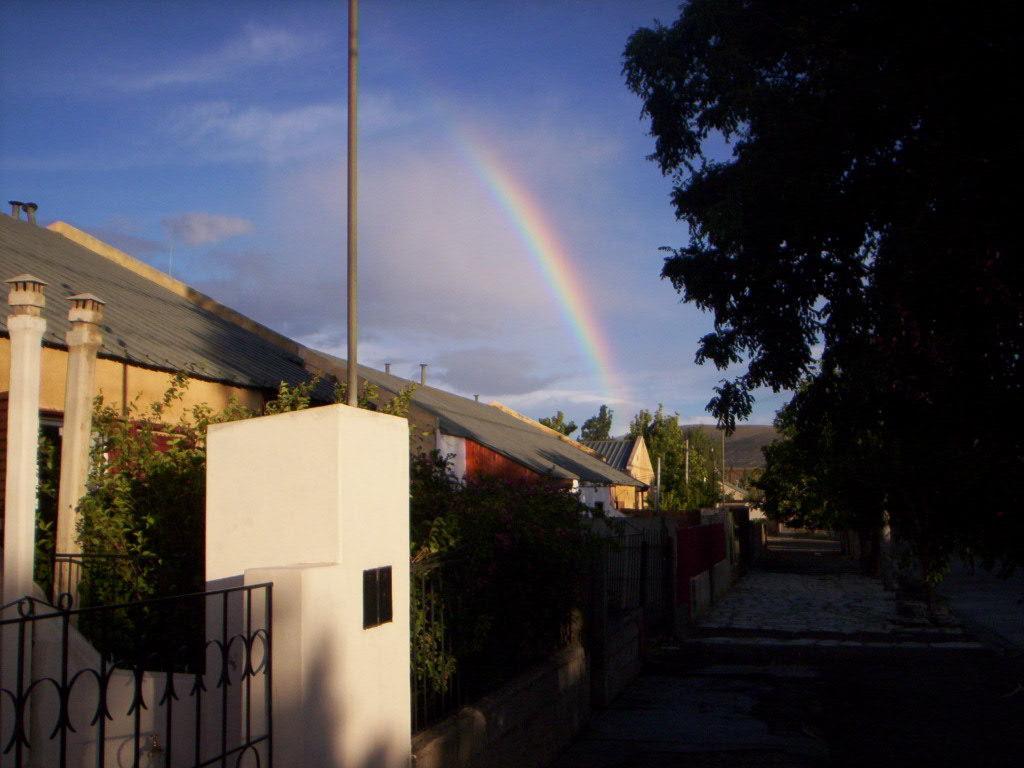Please provide a concise description of this image. In this picture I can see houses, fence and poles. On the right side I can see trees. In the background I can see the rainbow and the sky. 